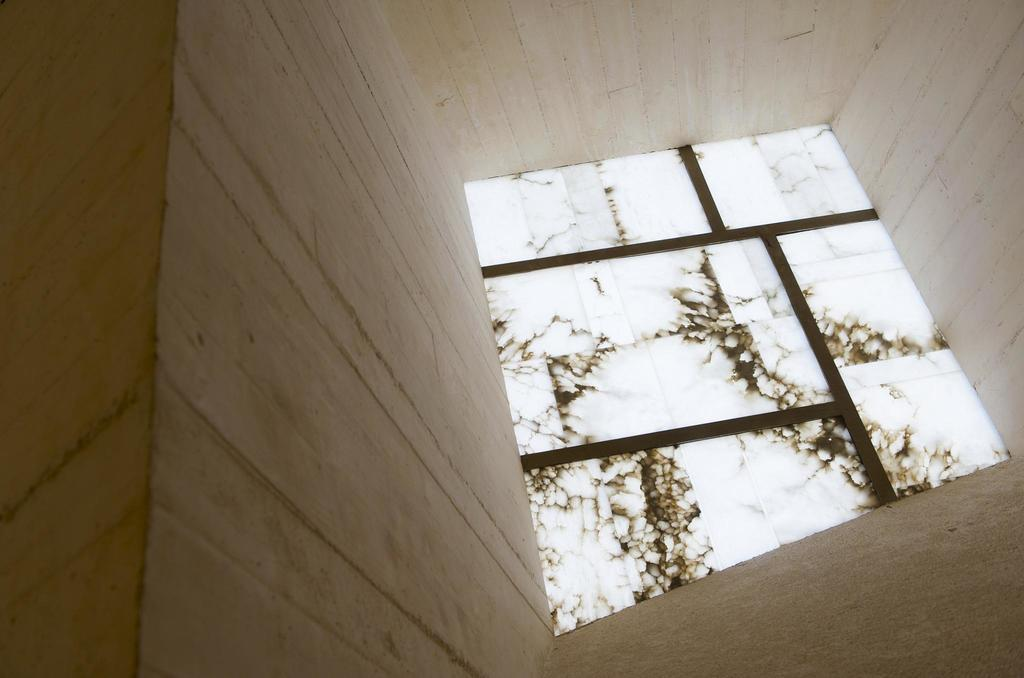What is located on the left side of the image? There is a wall on the left side of the image. What can be seen in the middle of the image? There is a glass window in the middle of the image. How many brothers are visible in the image? There are no brothers present in the image; it only features a wall and a glass window. What type of tank is located behind the wall in the image? There is no tank present behind the wall in the image. 